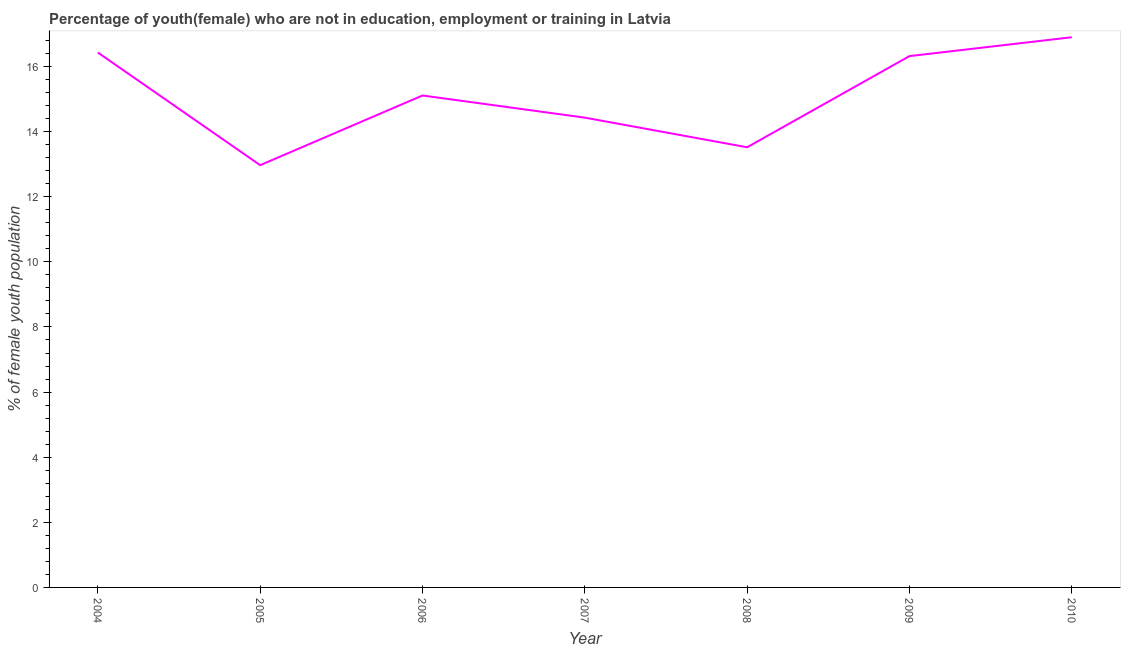What is the unemployed female youth population in 2007?
Keep it short and to the point. 14.43. Across all years, what is the maximum unemployed female youth population?
Keep it short and to the point. 16.9. Across all years, what is the minimum unemployed female youth population?
Give a very brief answer. 12.97. What is the sum of the unemployed female youth population?
Ensure brevity in your answer.  105.68. What is the difference between the unemployed female youth population in 2004 and 2005?
Your response must be concise. 3.46. What is the average unemployed female youth population per year?
Ensure brevity in your answer.  15.1. What is the median unemployed female youth population?
Provide a short and direct response. 15.11. In how many years, is the unemployed female youth population greater than 8.4 %?
Give a very brief answer. 7. What is the ratio of the unemployed female youth population in 2008 to that in 2009?
Your response must be concise. 0.83. What is the difference between the highest and the second highest unemployed female youth population?
Your answer should be very brief. 0.47. What is the difference between the highest and the lowest unemployed female youth population?
Make the answer very short. 3.93. In how many years, is the unemployed female youth population greater than the average unemployed female youth population taken over all years?
Offer a terse response. 4. Does the unemployed female youth population monotonically increase over the years?
Make the answer very short. No. How many lines are there?
Offer a terse response. 1. What is the difference between two consecutive major ticks on the Y-axis?
Make the answer very short. 2. Does the graph contain grids?
Offer a very short reply. No. What is the title of the graph?
Provide a succinct answer. Percentage of youth(female) who are not in education, employment or training in Latvia. What is the label or title of the X-axis?
Provide a short and direct response. Year. What is the label or title of the Y-axis?
Give a very brief answer. % of female youth population. What is the % of female youth population of 2004?
Give a very brief answer. 16.43. What is the % of female youth population in 2005?
Offer a terse response. 12.97. What is the % of female youth population of 2006?
Make the answer very short. 15.11. What is the % of female youth population of 2007?
Your answer should be very brief. 14.43. What is the % of female youth population in 2008?
Give a very brief answer. 13.52. What is the % of female youth population in 2009?
Your answer should be very brief. 16.32. What is the % of female youth population of 2010?
Your answer should be compact. 16.9. What is the difference between the % of female youth population in 2004 and 2005?
Your answer should be compact. 3.46. What is the difference between the % of female youth population in 2004 and 2006?
Your response must be concise. 1.32. What is the difference between the % of female youth population in 2004 and 2008?
Provide a short and direct response. 2.91. What is the difference between the % of female youth population in 2004 and 2009?
Your response must be concise. 0.11. What is the difference between the % of female youth population in 2004 and 2010?
Give a very brief answer. -0.47. What is the difference between the % of female youth population in 2005 and 2006?
Keep it short and to the point. -2.14. What is the difference between the % of female youth population in 2005 and 2007?
Ensure brevity in your answer.  -1.46. What is the difference between the % of female youth population in 2005 and 2008?
Offer a terse response. -0.55. What is the difference between the % of female youth population in 2005 and 2009?
Your answer should be very brief. -3.35. What is the difference between the % of female youth population in 2005 and 2010?
Provide a succinct answer. -3.93. What is the difference between the % of female youth population in 2006 and 2007?
Your answer should be compact. 0.68. What is the difference between the % of female youth population in 2006 and 2008?
Keep it short and to the point. 1.59. What is the difference between the % of female youth population in 2006 and 2009?
Give a very brief answer. -1.21. What is the difference between the % of female youth population in 2006 and 2010?
Ensure brevity in your answer.  -1.79. What is the difference between the % of female youth population in 2007 and 2008?
Ensure brevity in your answer.  0.91. What is the difference between the % of female youth population in 2007 and 2009?
Your response must be concise. -1.89. What is the difference between the % of female youth population in 2007 and 2010?
Provide a succinct answer. -2.47. What is the difference between the % of female youth population in 2008 and 2009?
Offer a very short reply. -2.8. What is the difference between the % of female youth population in 2008 and 2010?
Keep it short and to the point. -3.38. What is the difference between the % of female youth population in 2009 and 2010?
Ensure brevity in your answer.  -0.58. What is the ratio of the % of female youth population in 2004 to that in 2005?
Your response must be concise. 1.27. What is the ratio of the % of female youth population in 2004 to that in 2006?
Your answer should be compact. 1.09. What is the ratio of the % of female youth population in 2004 to that in 2007?
Offer a very short reply. 1.14. What is the ratio of the % of female youth population in 2004 to that in 2008?
Your answer should be very brief. 1.22. What is the ratio of the % of female youth population in 2005 to that in 2006?
Provide a succinct answer. 0.86. What is the ratio of the % of female youth population in 2005 to that in 2007?
Make the answer very short. 0.9. What is the ratio of the % of female youth population in 2005 to that in 2009?
Your response must be concise. 0.8. What is the ratio of the % of female youth population in 2005 to that in 2010?
Offer a very short reply. 0.77. What is the ratio of the % of female youth population in 2006 to that in 2007?
Offer a very short reply. 1.05. What is the ratio of the % of female youth population in 2006 to that in 2008?
Keep it short and to the point. 1.12. What is the ratio of the % of female youth population in 2006 to that in 2009?
Your answer should be very brief. 0.93. What is the ratio of the % of female youth population in 2006 to that in 2010?
Offer a very short reply. 0.89. What is the ratio of the % of female youth population in 2007 to that in 2008?
Provide a succinct answer. 1.07. What is the ratio of the % of female youth population in 2007 to that in 2009?
Keep it short and to the point. 0.88. What is the ratio of the % of female youth population in 2007 to that in 2010?
Offer a very short reply. 0.85. What is the ratio of the % of female youth population in 2008 to that in 2009?
Make the answer very short. 0.83. What is the ratio of the % of female youth population in 2009 to that in 2010?
Your response must be concise. 0.97. 